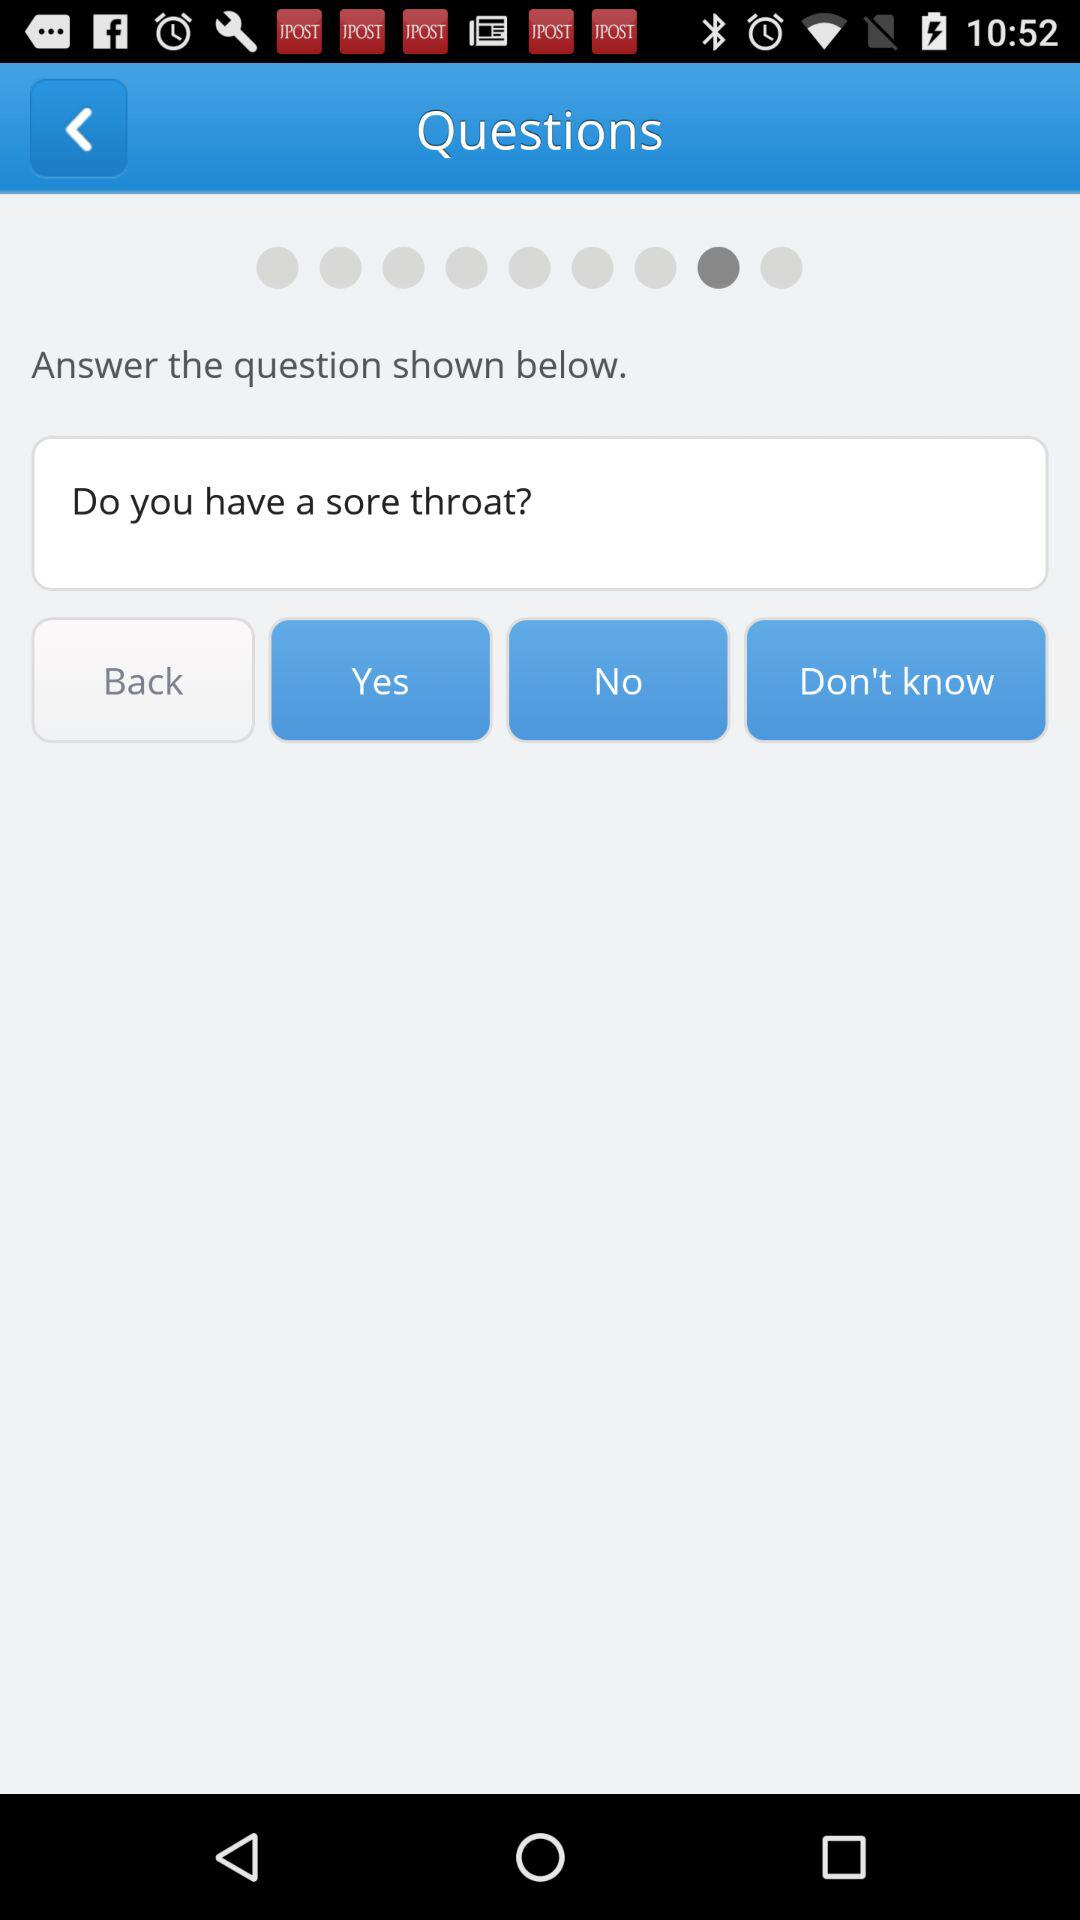Which tab is not selected?
When the provided information is insufficient, respond with <no answer>. <no answer> 